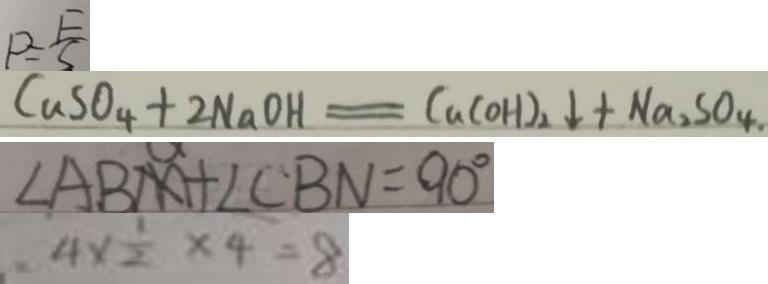Convert formula to latex. <formula><loc_0><loc_0><loc_500><loc_500>P = \frac { F } { S } 
 C u S O _ { 4 } + 2 N a O H = C u ( O H ) _ { 2 } \downarrow + N a _ { 2 } S O _ { 4 \cdot } 
 \angle A B M + \angle C B N = 9 0 ^ { \circ } 
 4 \times \frac { 1 } { 2 } \times 4 = 8</formula> 